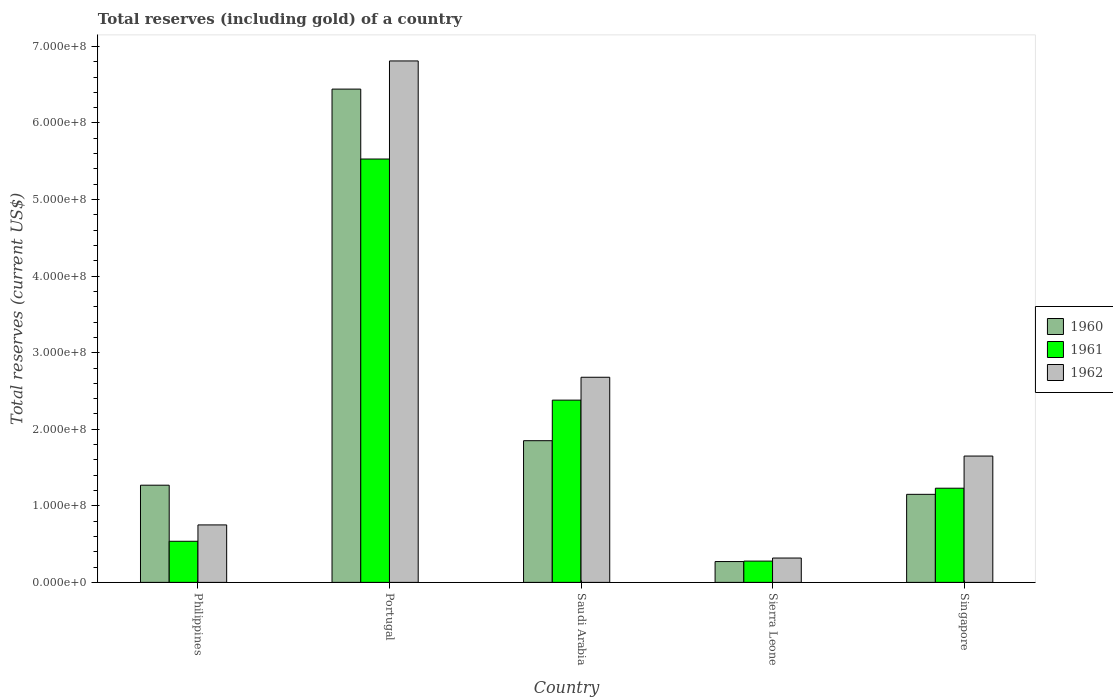How many different coloured bars are there?
Provide a short and direct response. 3. Are the number of bars on each tick of the X-axis equal?
Your response must be concise. Yes. How many bars are there on the 1st tick from the left?
Your answer should be very brief. 3. In how many cases, is the number of bars for a given country not equal to the number of legend labels?
Make the answer very short. 0. What is the total reserves (including gold) in 1961 in Sierra Leone?
Ensure brevity in your answer.  2.78e+07. Across all countries, what is the maximum total reserves (including gold) in 1962?
Ensure brevity in your answer.  6.81e+08. Across all countries, what is the minimum total reserves (including gold) in 1962?
Give a very brief answer. 3.18e+07. In which country was the total reserves (including gold) in 1962 maximum?
Provide a succinct answer. Portugal. In which country was the total reserves (including gold) in 1960 minimum?
Keep it short and to the point. Sierra Leone. What is the total total reserves (including gold) in 1961 in the graph?
Provide a short and direct response. 9.95e+08. What is the difference between the total reserves (including gold) in 1960 in Saudi Arabia and that in Singapore?
Provide a succinct answer. 7.01e+07. What is the difference between the total reserves (including gold) in 1962 in Philippines and the total reserves (including gold) in 1961 in Portugal?
Ensure brevity in your answer.  -4.78e+08. What is the average total reserves (including gold) in 1962 per country?
Offer a terse response. 2.44e+08. What is the difference between the total reserves (including gold) of/in 1962 and total reserves (including gold) of/in 1960 in Sierra Leone?
Your response must be concise. 4.60e+06. What is the ratio of the total reserves (including gold) in 1960 in Philippines to that in Sierra Leone?
Offer a very short reply. 4.67. What is the difference between the highest and the second highest total reserves (including gold) in 1962?
Offer a very short reply. -1.03e+08. What is the difference between the highest and the lowest total reserves (including gold) in 1961?
Give a very brief answer. 5.25e+08. Is the sum of the total reserves (including gold) in 1961 in Portugal and Sierra Leone greater than the maximum total reserves (including gold) in 1960 across all countries?
Ensure brevity in your answer.  No. How many bars are there?
Offer a very short reply. 15. Are all the bars in the graph horizontal?
Offer a very short reply. No. What is the difference between two consecutive major ticks on the Y-axis?
Your response must be concise. 1.00e+08. Where does the legend appear in the graph?
Ensure brevity in your answer.  Center right. How are the legend labels stacked?
Offer a very short reply. Vertical. What is the title of the graph?
Offer a terse response. Total reserves (including gold) of a country. What is the label or title of the X-axis?
Your response must be concise. Country. What is the label or title of the Y-axis?
Provide a short and direct response. Total reserves (current US$). What is the Total reserves (current US$) of 1960 in Philippines?
Your response must be concise. 1.27e+08. What is the Total reserves (current US$) of 1961 in Philippines?
Your response must be concise. 5.37e+07. What is the Total reserves (current US$) in 1962 in Philippines?
Make the answer very short. 7.51e+07. What is the Total reserves (current US$) in 1960 in Portugal?
Make the answer very short. 6.44e+08. What is the Total reserves (current US$) of 1961 in Portugal?
Your answer should be compact. 5.53e+08. What is the Total reserves (current US$) of 1962 in Portugal?
Offer a very short reply. 6.81e+08. What is the Total reserves (current US$) in 1960 in Saudi Arabia?
Provide a succinct answer. 1.85e+08. What is the Total reserves (current US$) in 1961 in Saudi Arabia?
Ensure brevity in your answer.  2.38e+08. What is the Total reserves (current US$) of 1962 in Saudi Arabia?
Your answer should be very brief. 2.68e+08. What is the Total reserves (current US$) of 1960 in Sierra Leone?
Your answer should be very brief. 2.72e+07. What is the Total reserves (current US$) in 1961 in Sierra Leone?
Make the answer very short. 2.78e+07. What is the Total reserves (current US$) of 1962 in Sierra Leone?
Offer a very short reply. 3.18e+07. What is the Total reserves (current US$) of 1960 in Singapore?
Your answer should be very brief. 1.15e+08. What is the Total reserves (current US$) of 1961 in Singapore?
Ensure brevity in your answer.  1.23e+08. What is the Total reserves (current US$) of 1962 in Singapore?
Make the answer very short. 1.65e+08. Across all countries, what is the maximum Total reserves (current US$) in 1960?
Keep it short and to the point. 6.44e+08. Across all countries, what is the maximum Total reserves (current US$) in 1961?
Make the answer very short. 5.53e+08. Across all countries, what is the maximum Total reserves (current US$) of 1962?
Keep it short and to the point. 6.81e+08. Across all countries, what is the minimum Total reserves (current US$) in 1960?
Keep it short and to the point. 2.72e+07. Across all countries, what is the minimum Total reserves (current US$) of 1961?
Make the answer very short. 2.78e+07. Across all countries, what is the minimum Total reserves (current US$) of 1962?
Provide a succinct answer. 3.18e+07. What is the total Total reserves (current US$) in 1960 in the graph?
Your answer should be very brief. 1.10e+09. What is the total Total reserves (current US$) of 1961 in the graph?
Your answer should be compact. 9.95e+08. What is the total Total reserves (current US$) in 1962 in the graph?
Provide a short and direct response. 1.22e+09. What is the difference between the Total reserves (current US$) in 1960 in Philippines and that in Portugal?
Make the answer very short. -5.17e+08. What is the difference between the Total reserves (current US$) in 1961 in Philippines and that in Portugal?
Your answer should be very brief. -4.99e+08. What is the difference between the Total reserves (current US$) of 1962 in Philippines and that in Portugal?
Provide a short and direct response. -6.06e+08. What is the difference between the Total reserves (current US$) of 1960 in Philippines and that in Saudi Arabia?
Your response must be concise. -5.81e+07. What is the difference between the Total reserves (current US$) in 1961 in Philippines and that in Saudi Arabia?
Keep it short and to the point. -1.84e+08. What is the difference between the Total reserves (current US$) in 1962 in Philippines and that in Saudi Arabia?
Ensure brevity in your answer.  -1.93e+08. What is the difference between the Total reserves (current US$) of 1960 in Philippines and that in Sierra Leone?
Your answer should be compact. 9.97e+07. What is the difference between the Total reserves (current US$) of 1961 in Philippines and that in Sierra Leone?
Keep it short and to the point. 2.59e+07. What is the difference between the Total reserves (current US$) in 1962 in Philippines and that in Sierra Leone?
Ensure brevity in your answer.  4.33e+07. What is the difference between the Total reserves (current US$) in 1960 in Philippines and that in Singapore?
Make the answer very short. 1.19e+07. What is the difference between the Total reserves (current US$) of 1961 in Philippines and that in Singapore?
Offer a very short reply. -6.93e+07. What is the difference between the Total reserves (current US$) of 1962 in Philippines and that in Singapore?
Ensure brevity in your answer.  -8.99e+07. What is the difference between the Total reserves (current US$) of 1960 in Portugal and that in Saudi Arabia?
Your answer should be very brief. 4.59e+08. What is the difference between the Total reserves (current US$) in 1961 in Portugal and that in Saudi Arabia?
Provide a short and direct response. 3.15e+08. What is the difference between the Total reserves (current US$) in 1962 in Portugal and that in Saudi Arabia?
Provide a short and direct response. 4.13e+08. What is the difference between the Total reserves (current US$) of 1960 in Portugal and that in Sierra Leone?
Offer a very short reply. 6.17e+08. What is the difference between the Total reserves (current US$) of 1961 in Portugal and that in Sierra Leone?
Make the answer very short. 5.25e+08. What is the difference between the Total reserves (current US$) of 1962 in Portugal and that in Sierra Leone?
Give a very brief answer. 6.49e+08. What is the difference between the Total reserves (current US$) in 1960 in Portugal and that in Singapore?
Your answer should be very brief. 5.29e+08. What is the difference between the Total reserves (current US$) in 1961 in Portugal and that in Singapore?
Offer a terse response. 4.30e+08. What is the difference between the Total reserves (current US$) of 1962 in Portugal and that in Singapore?
Provide a succinct answer. 5.16e+08. What is the difference between the Total reserves (current US$) in 1960 in Saudi Arabia and that in Sierra Leone?
Ensure brevity in your answer.  1.58e+08. What is the difference between the Total reserves (current US$) in 1961 in Saudi Arabia and that in Sierra Leone?
Your response must be concise. 2.10e+08. What is the difference between the Total reserves (current US$) in 1962 in Saudi Arabia and that in Sierra Leone?
Keep it short and to the point. 2.36e+08. What is the difference between the Total reserves (current US$) of 1960 in Saudi Arabia and that in Singapore?
Offer a very short reply. 7.01e+07. What is the difference between the Total reserves (current US$) in 1961 in Saudi Arabia and that in Singapore?
Your answer should be compact. 1.15e+08. What is the difference between the Total reserves (current US$) of 1962 in Saudi Arabia and that in Singapore?
Your answer should be compact. 1.03e+08. What is the difference between the Total reserves (current US$) in 1960 in Sierra Leone and that in Singapore?
Your response must be concise. -8.78e+07. What is the difference between the Total reserves (current US$) of 1961 in Sierra Leone and that in Singapore?
Ensure brevity in your answer.  -9.52e+07. What is the difference between the Total reserves (current US$) of 1962 in Sierra Leone and that in Singapore?
Give a very brief answer. -1.33e+08. What is the difference between the Total reserves (current US$) in 1960 in Philippines and the Total reserves (current US$) in 1961 in Portugal?
Provide a short and direct response. -4.26e+08. What is the difference between the Total reserves (current US$) in 1960 in Philippines and the Total reserves (current US$) in 1962 in Portugal?
Ensure brevity in your answer.  -5.54e+08. What is the difference between the Total reserves (current US$) in 1961 in Philippines and the Total reserves (current US$) in 1962 in Portugal?
Keep it short and to the point. -6.27e+08. What is the difference between the Total reserves (current US$) in 1960 in Philippines and the Total reserves (current US$) in 1961 in Saudi Arabia?
Ensure brevity in your answer.  -1.11e+08. What is the difference between the Total reserves (current US$) of 1960 in Philippines and the Total reserves (current US$) of 1962 in Saudi Arabia?
Your answer should be very brief. -1.41e+08. What is the difference between the Total reserves (current US$) of 1961 in Philippines and the Total reserves (current US$) of 1962 in Saudi Arabia?
Provide a succinct answer. -2.14e+08. What is the difference between the Total reserves (current US$) in 1960 in Philippines and the Total reserves (current US$) in 1961 in Sierra Leone?
Give a very brief answer. 9.91e+07. What is the difference between the Total reserves (current US$) in 1960 in Philippines and the Total reserves (current US$) in 1962 in Sierra Leone?
Offer a terse response. 9.51e+07. What is the difference between the Total reserves (current US$) of 1961 in Philippines and the Total reserves (current US$) of 1962 in Sierra Leone?
Your answer should be compact. 2.19e+07. What is the difference between the Total reserves (current US$) of 1960 in Philippines and the Total reserves (current US$) of 1961 in Singapore?
Your answer should be very brief. 3.94e+06. What is the difference between the Total reserves (current US$) in 1960 in Philippines and the Total reserves (current US$) in 1962 in Singapore?
Your answer should be compact. -3.81e+07. What is the difference between the Total reserves (current US$) of 1961 in Philippines and the Total reserves (current US$) of 1962 in Singapore?
Your answer should be compact. -1.11e+08. What is the difference between the Total reserves (current US$) in 1960 in Portugal and the Total reserves (current US$) in 1961 in Saudi Arabia?
Your answer should be very brief. 4.06e+08. What is the difference between the Total reserves (current US$) of 1960 in Portugal and the Total reserves (current US$) of 1962 in Saudi Arabia?
Your answer should be very brief. 3.76e+08. What is the difference between the Total reserves (current US$) of 1961 in Portugal and the Total reserves (current US$) of 1962 in Saudi Arabia?
Offer a very short reply. 2.85e+08. What is the difference between the Total reserves (current US$) of 1960 in Portugal and the Total reserves (current US$) of 1961 in Sierra Leone?
Ensure brevity in your answer.  6.16e+08. What is the difference between the Total reserves (current US$) in 1960 in Portugal and the Total reserves (current US$) in 1962 in Sierra Leone?
Your answer should be very brief. 6.12e+08. What is the difference between the Total reserves (current US$) in 1961 in Portugal and the Total reserves (current US$) in 1962 in Sierra Leone?
Ensure brevity in your answer.  5.21e+08. What is the difference between the Total reserves (current US$) of 1960 in Portugal and the Total reserves (current US$) of 1961 in Singapore?
Your response must be concise. 5.21e+08. What is the difference between the Total reserves (current US$) of 1960 in Portugal and the Total reserves (current US$) of 1962 in Singapore?
Offer a terse response. 4.79e+08. What is the difference between the Total reserves (current US$) of 1961 in Portugal and the Total reserves (current US$) of 1962 in Singapore?
Provide a succinct answer. 3.88e+08. What is the difference between the Total reserves (current US$) of 1960 in Saudi Arabia and the Total reserves (current US$) of 1961 in Sierra Leone?
Offer a terse response. 1.57e+08. What is the difference between the Total reserves (current US$) in 1960 in Saudi Arabia and the Total reserves (current US$) in 1962 in Sierra Leone?
Your answer should be compact. 1.53e+08. What is the difference between the Total reserves (current US$) in 1961 in Saudi Arabia and the Total reserves (current US$) in 1962 in Sierra Leone?
Provide a short and direct response. 2.06e+08. What is the difference between the Total reserves (current US$) of 1960 in Saudi Arabia and the Total reserves (current US$) of 1961 in Singapore?
Make the answer very short. 6.21e+07. What is the difference between the Total reserves (current US$) in 1960 in Saudi Arabia and the Total reserves (current US$) in 1962 in Singapore?
Give a very brief answer. 2.01e+07. What is the difference between the Total reserves (current US$) of 1961 in Saudi Arabia and the Total reserves (current US$) of 1962 in Singapore?
Provide a succinct answer. 7.30e+07. What is the difference between the Total reserves (current US$) in 1960 in Sierra Leone and the Total reserves (current US$) in 1961 in Singapore?
Your response must be concise. -9.58e+07. What is the difference between the Total reserves (current US$) of 1960 in Sierra Leone and the Total reserves (current US$) of 1962 in Singapore?
Your answer should be very brief. -1.38e+08. What is the difference between the Total reserves (current US$) in 1961 in Sierra Leone and the Total reserves (current US$) in 1962 in Singapore?
Your answer should be very brief. -1.37e+08. What is the average Total reserves (current US$) of 1960 per country?
Give a very brief answer. 2.20e+08. What is the average Total reserves (current US$) of 1961 per country?
Give a very brief answer. 1.99e+08. What is the average Total reserves (current US$) of 1962 per country?
Offer a very short reply. 2.44e+08. What is the difference between the Total reserves (current US$) in 1960 and Total reserves (current US$) in 1961 in Philippines?
Ensure brevity in your answer.  7.33e+07. What is the difference between the Total reserves (current US$) in 1960 and Total reserves (current US$) in 1962 in Philippines?
Give a very brief answer. 5.19e+07. What is the difference between the Total reserves (current US$) in 1961 and Total reserves (current US$) in 1962 in Philippines?
Provide a succinct answer. -2.14e+07. What is the difference between the Total reserves (current US$) in 1960 and Total reserves (current US$) in 1961 in Portugal?
Keep it short and to the point. 9.13e+07. What is the difference between the Total reserves (current US$) of 1960 and Total reserves (current US$) of 1962 in Portugal?
Provide a short and direct response. -3.68e+07. What is the difference between the Total reserves (current US$) in 1961 and Total reserves (current US$) in 1962 in Portugal?
Your response must be concise. -1.28e+08. What is the difference between the Total reserves (current US$) in 1960 and Total reserves (current US$) in 1961 in Saudi Arabia?
Provide a short and direct response. -5.30e+07. What is the difference between the Total reserves (current US$) in 1960 and Total reserves (current US$) in 1962 in Saudi Arabia?
Offer a terse response. -8.29e+07. What is the difference between the Total reserves (current US$) of 1961 and Total reserves (current US$) of 1962 in Saudi Arabia?
Provide a succinct answer. -2.99e+07. What is the difference between the Total reserves (current US$) of 1960 and Total reserves (current US$) of 1961 in Sierra Leone?
Give a very brief answer. -6.00e+05. What is the difference between the Total reserves (current US$) of 1960 and Total reserves (current US$) of 1962 in Sierra Leone?
Your answer should be very brief. -4.60e+06. What is the difference between the Total reserves (current US$) in 1960 and Total reserves (current US$) in 1961 in Singapore?
Offer a very short reply. -8.00e+06. What is the difference between the Total reserves (current US$) of 1960 and Total reserves (current US$) of 1962 in Singapore?
Keep it short and to the point. -5.00e+07. What is the difference between the Total reserves (current US$) in 1961 and Total reserves (current US$) in 1962 in Singapore?
Offer a terse response. -4.20e+07. What is the ratio of the Total reserves (current US$) of 1960 in Philippines to that in Portugal?
Give a very brief answer. 0.2. What is the ratio of the Total reserves (current US$) in 1961 in Philippines to that in Portugal?
Make the answer very short. 0.1. What is the ratio of the Total reserves (current US$) in 1962 in Philippines to that in Portugal?
Keep it short and to the point. 0.11. What is the ratio of the Total reserves (current US$) in 1960 in Philippines to that in Saudi Arabia?
Keep it short and to the point. 0.69. What is the ratio of the Total reserves (current US$) of 1961 in Philippines to that in Saudi Arabia?
Give a very brief answer. 0.23. What is the ratio of the Total reserves (current US$) in 1962 in Philippines to that in Saudi Arabia?
Your response must be concise. 0.28. What is the ratio of the Total reserves (current US$) of 1960 in Philippines to that in Sierra Leone?
Your answer should be very brief. 4.67. What is the ratio of the Total reserves (current US$) in 1961 in Philippines to that in Sierra Leone?
Your response must be concise. 1.93. What is the ratio of the Total reserves (current US$) of 1962 in Philippines to that in Sierra Leone?
Provide a succinct answer. 2.36. What is the ratio of the Total reserves (current US$) in 1960 in Philippines to that in Singapore?
Keep it short and to the point. 1.1. What is the ratio of the Total reserves (current US$) of 1961 in Philippines to that in Singapore?
Keep it short and to the point. 0.44. What is the ratio of the Total reserves (current US$) in 1962 in Philippines to that in Singapore?
Provide a short and direct response. 0.46. What is the ratio of the Total reserves (current US$) in 1960 in Portugal to that in Saudi Arabia?
Offer a terse response. 3.48. What is the ratio of the Total reserves (current US$) of 1961 in Portugal to that in Saudi Arabia?
Keep it short and to the point. 2.32. What is the ratio of the Total reserves (current US$) in 1962 in Portugal to that in Saudi Arabia?
Offer a very short reply. 2.54. What is the ratio of the Total reserves (current US$) of 1960 in Portugal to that in Sierra Leone?
Your answer should be very brief. 23.69. What is the ratio of the Total reserves (current US$) in 1961 in Portugal to that in Sierra Leone?
Your response must be concise. 19.89. What is the ratio of the Total reserves (current US$) in 1962 in Portugal to that in Sierra Leone?
Your answer should be very brief. 21.42. What is the ratio of the Total reserves (current US$) in 1960 in Portugal to that in Singapore?
Provide a succinct answer. 5.6. What is the ratio of the Total reserves (current US$) in 1961 in Portugal to that in Singapore?
Offer a very short reply. 4.5. What is the ratio of the Total reserves (current US$) in 1962 in Portugal to that in Singapore?
Provide a short and direct response. 4.13. What is the ratio of the Total reserves (current US$) of 1960 in Saudi Arabia to that in Sierra Leone?
Give a very brief answer. 6.8. What is the ratio of the Total reserves (current US$) in 1961 in Saudi Arabia to that in Sierra Leone?
Make the answer very short. 8.56. What is the ratio of the Total reserves (current US$) in 1962 in Saudi Arabia to that in Sierra Leone?
Provide a succinct answer. 8.43. What is the ratio of the Total reserves (current US$) in 1960 in Saudi Arabia to that in Singapore?
Offer a very short reply. 1.61. What is the ratio of the Total reserves (current US$) of 1961 in Saudi Arabia to that in Singapore?
Ensure brevity in your answer.  1.94. What is the ratio of the Total reserves (current US$) in 1962 in Saudi Arabia to that in Singapore?
Offer a terse response. 1.62. What is the ratio of the Total reserves (current US$) in 1960 in Sierra Leone to that in Singapore?
Provide a short and direct response. 0.24. What is the ratio of the Total reserves (current US$) of 1961 in Sierra Leone to that in Singapore?
Ensure brevity in your answer.  0.23. What is the ratio of the Total reserves (current US$) of 1962 in Sierra Leone to that in Singapore?
Offer a terse response. 0.19. What is the difference between the highest and the second highest Total reserves (current US$) in 1960?
Give a very brief answer. 4.59e+08. What is the difference between the highest and the second highest Total reserves (current US$) of 1961?
Make the answer very short. 3.15e+08. What is the difference between the highest and the second highest Total reserves (current US$) in 1962?
Offer a terse response. 4.13e+08. What is the difference between the highest and the lowest Total reserves (current US$) of 1960?
Make the answer very short. 6.17e+08. What is the difference between the highest and the lowest Total reserves (current US$) of 1961?
Provide a short and direct response. 5.25e+08. What is the difference between the highest and the lowest Total reserves (current US$) in 1962?
Offer a very short reply. 6.49e+08. 